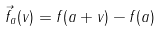<formula> <loc_0><loc_0><loc_500><loc_500>\vec { f } _ { a } ( v ) = f ( a + v ) - f ( a )</formula> 